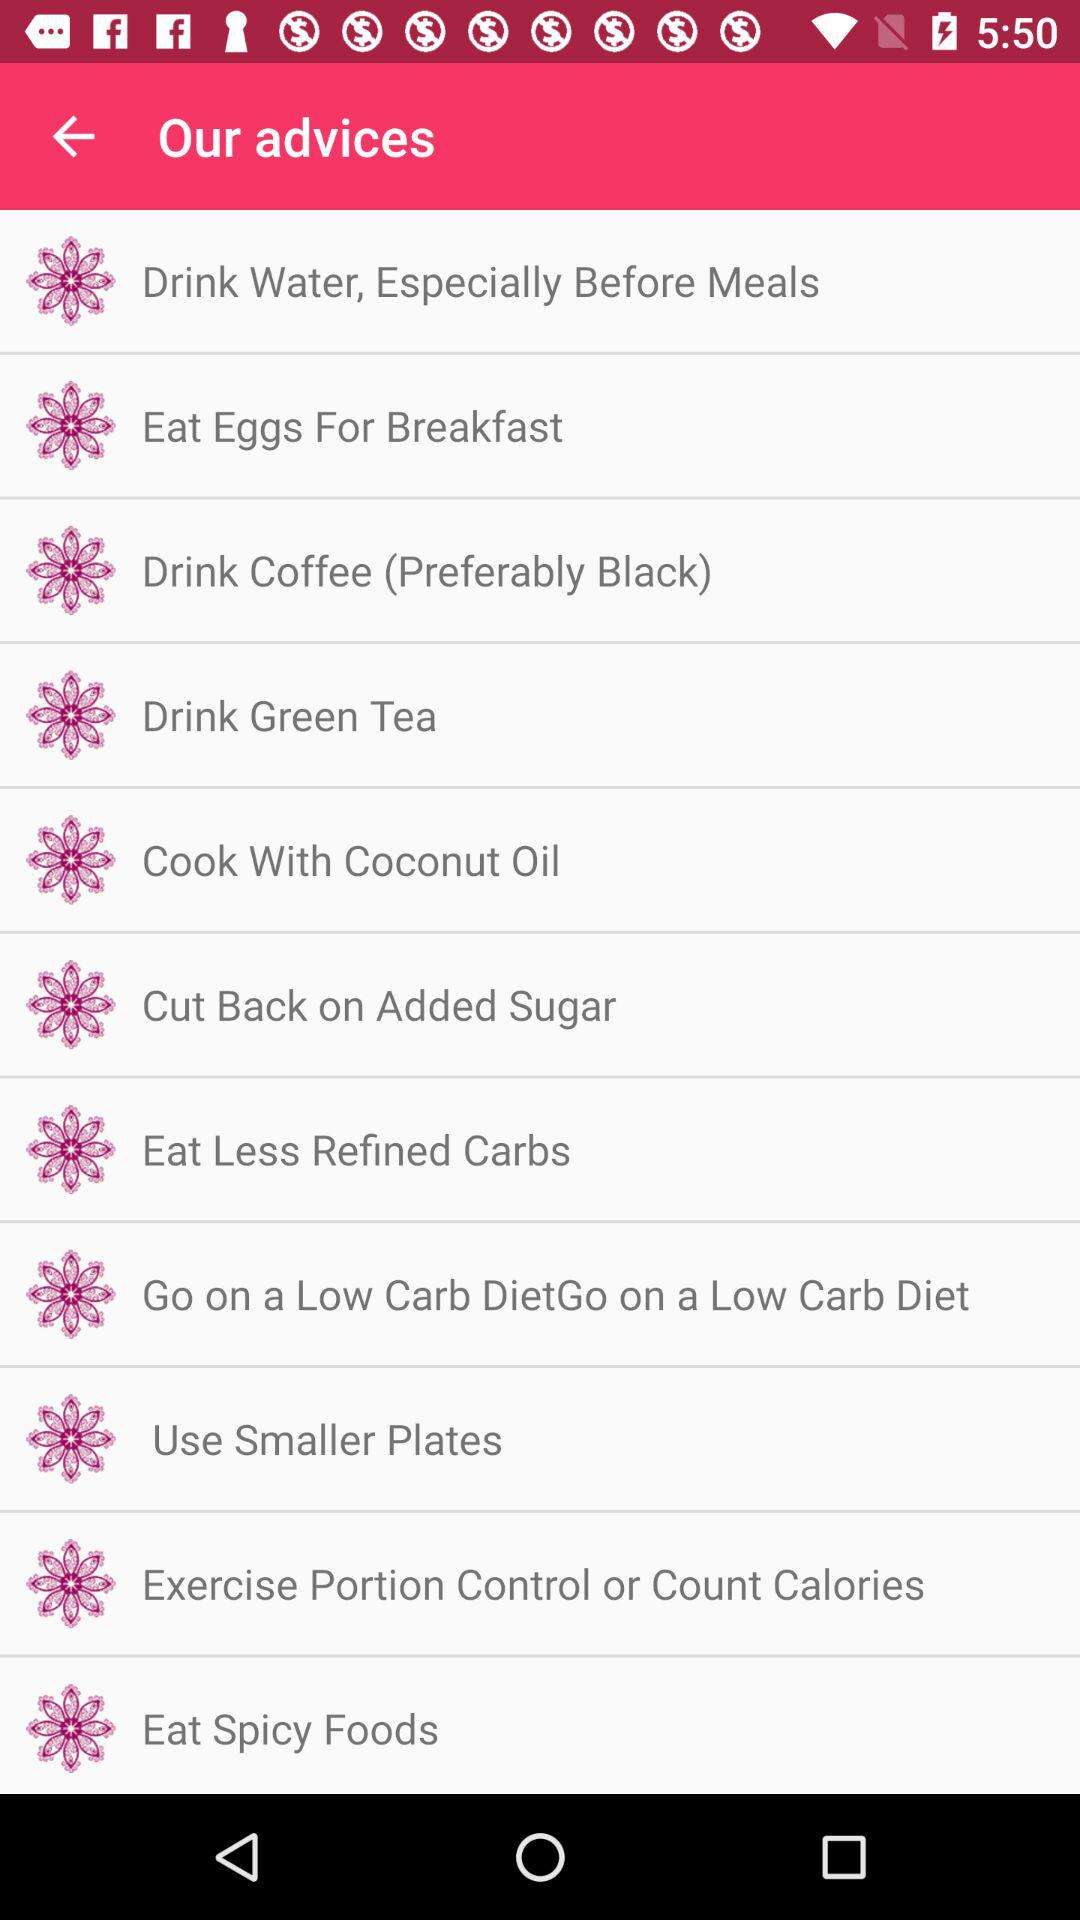How many advices are about drinking?
Answer the question using a single word or phrase. 3 